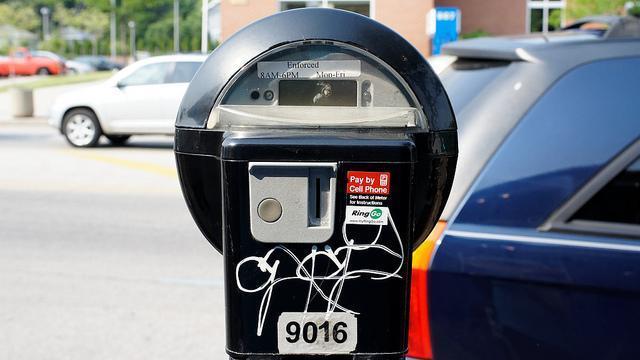How many vehicles can this device serve?
Give a very brief answer. 1. How many cars can be seen?
Give a very brief answer. 2. How many people reaching for the frisbee are wearing red?
Give a very brief answer. 0. 